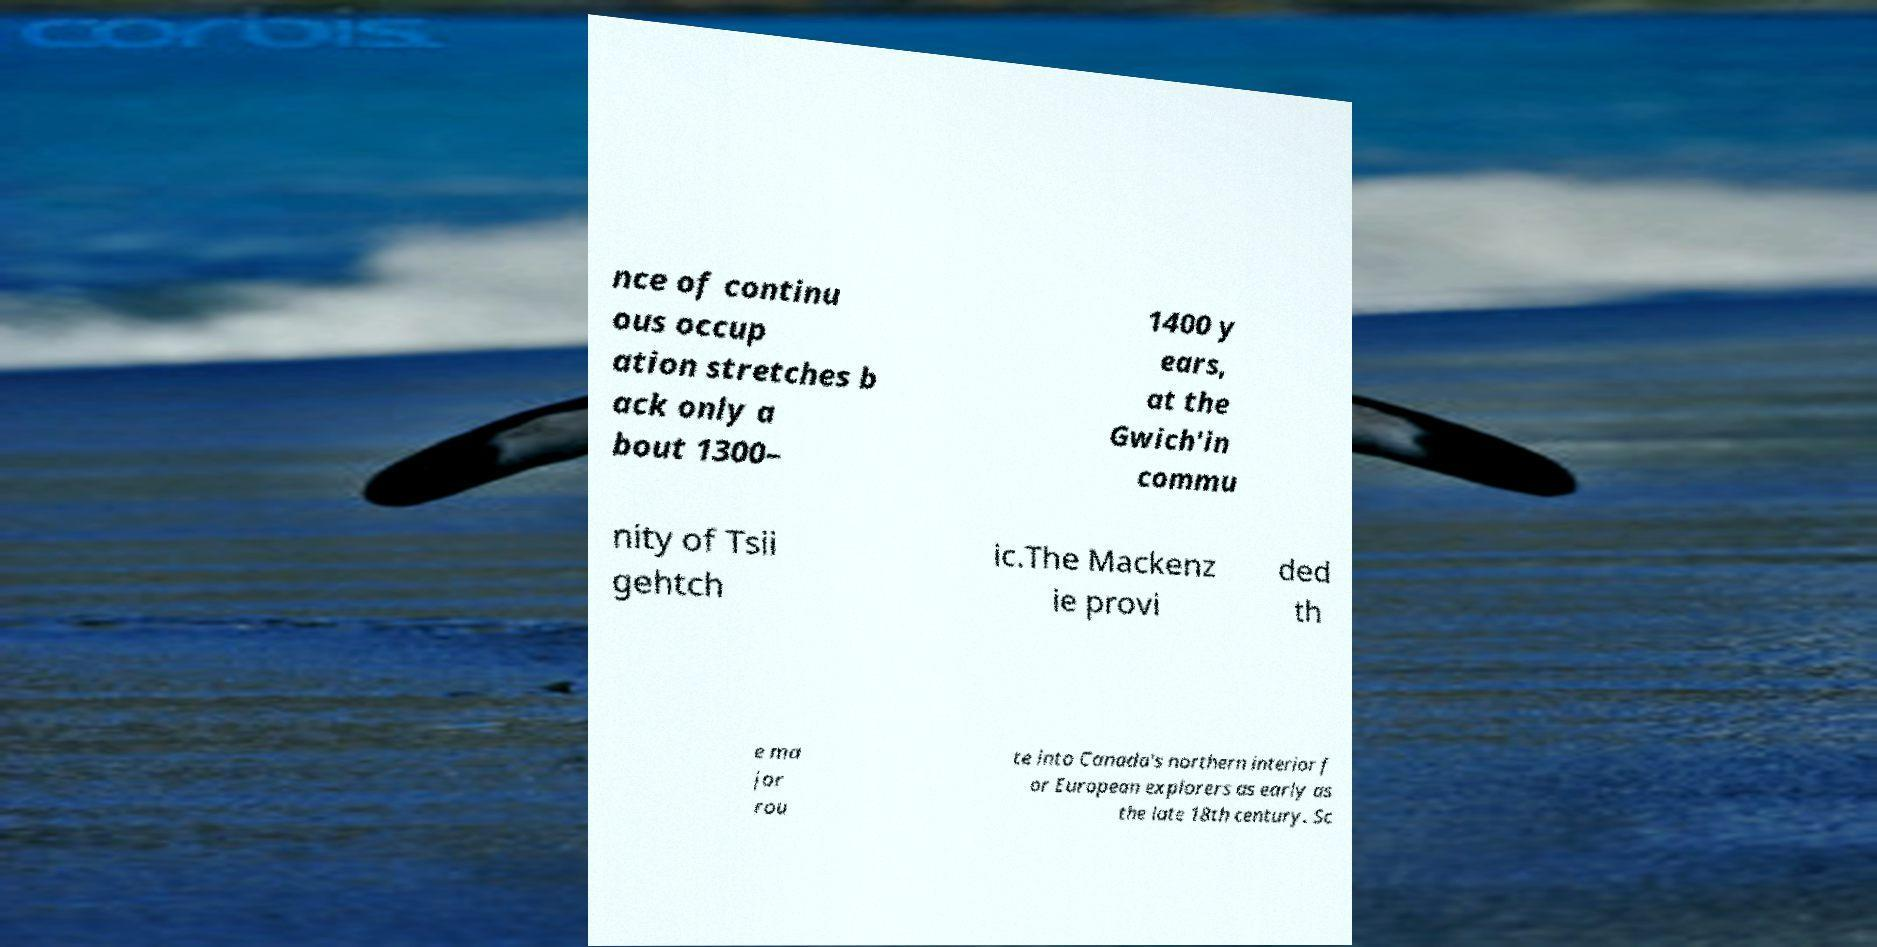Could you extract and type out the text from this image? nce of continu ous occup ation stretches b ack only a bout 1300– 1400 y ears, at the Gwich'in commu nity of Tsii gehtch ic.The Mackenz ie provi ded th e ma jor rou te into Canada's northern interior f or European explorers as early as the late 18th century. Sc 